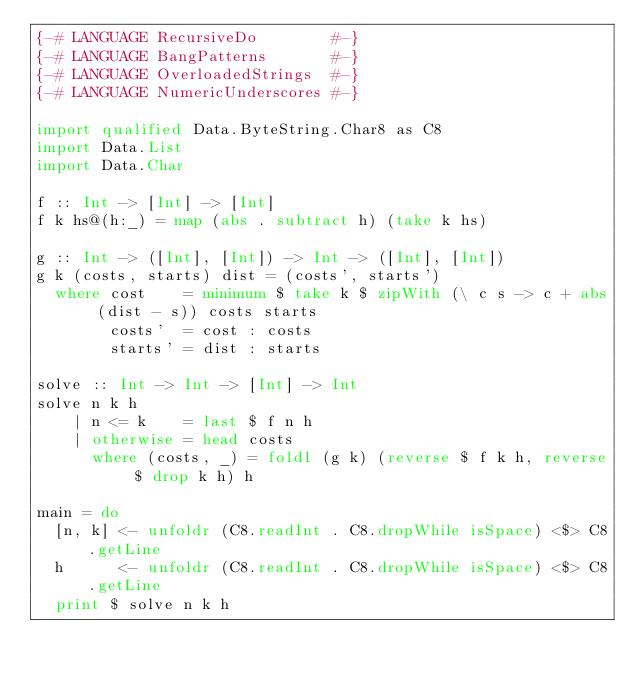Convert code to text. <code><loc_0><loc_0><loc_500><loc_500><_Haskell_>{-# LANGUAGE RecursiveDo        #-}
{-# LANGUAGE BangPatterns       #-}
{-# LANGUAGE OverloadedStrings  #-}
{-# LANGUAGE NumericUnderscores #-}

import qualified Data.ByteString.Char8 as C8
import Data.List
import Data.Char

f :: Int -> [Int] -> [Int]
f k hs@(h:_) = map (abs . subtract h) (take k hs)

g :: Int -> ([Int], [Int]) -> Int -> ([Int], [Int])
g k (costs, starts) dist = (costs', starts')
  where cost    = minimum $ take k $ zipWith (\ c s -> c + abs (dist - s)) costs starts
        costs'  = cost : costs
        starts' = dist : starts

solve :: Int -> Int -> [Int] -> Int
solve n k h
    | n <= k    = last $ f n h
    | otherwise = head costs
      where (costs, _) = foldl (g k) (reverse $ f k h, reverse $ drop k h) h

main = do
  [n, k] <- unfoldr (C8.readInt . C8.dropWhile isSpace) <$> C8.getLine
  h      <- unfoldr (C8.readInt . C8.dropWhile isSpace) <$> C8.getLine
  print $ solve n k h
</code> 